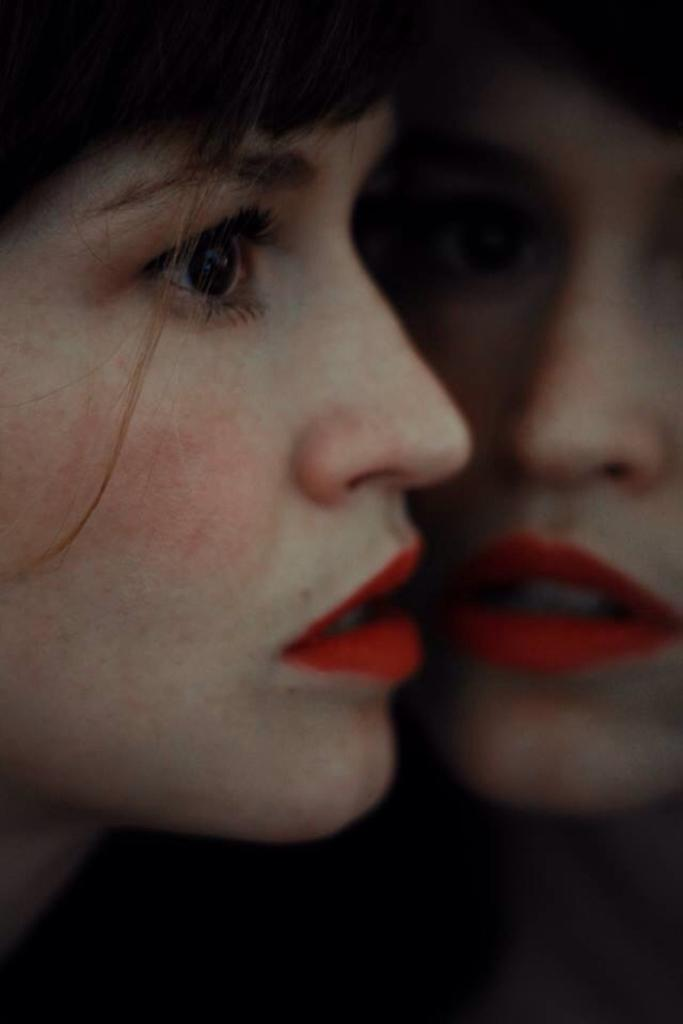What is the main subject of the image? The main subject of the image is a woman's face. Where is the woman's face located in the image? The woman's face is on a mirror. Is there a reflection of the woman's face in the image? Yes, there is a similar image of the woman's face in the mirror. What type of disgust can be seen on the actor's face in the image? There is no actor present in the image, and the woman's face does not display any disgust. What is the woman's face doing in the basin in the image? There is no basin present in the image, and the woman's face is on a mirror, not in a basin. 